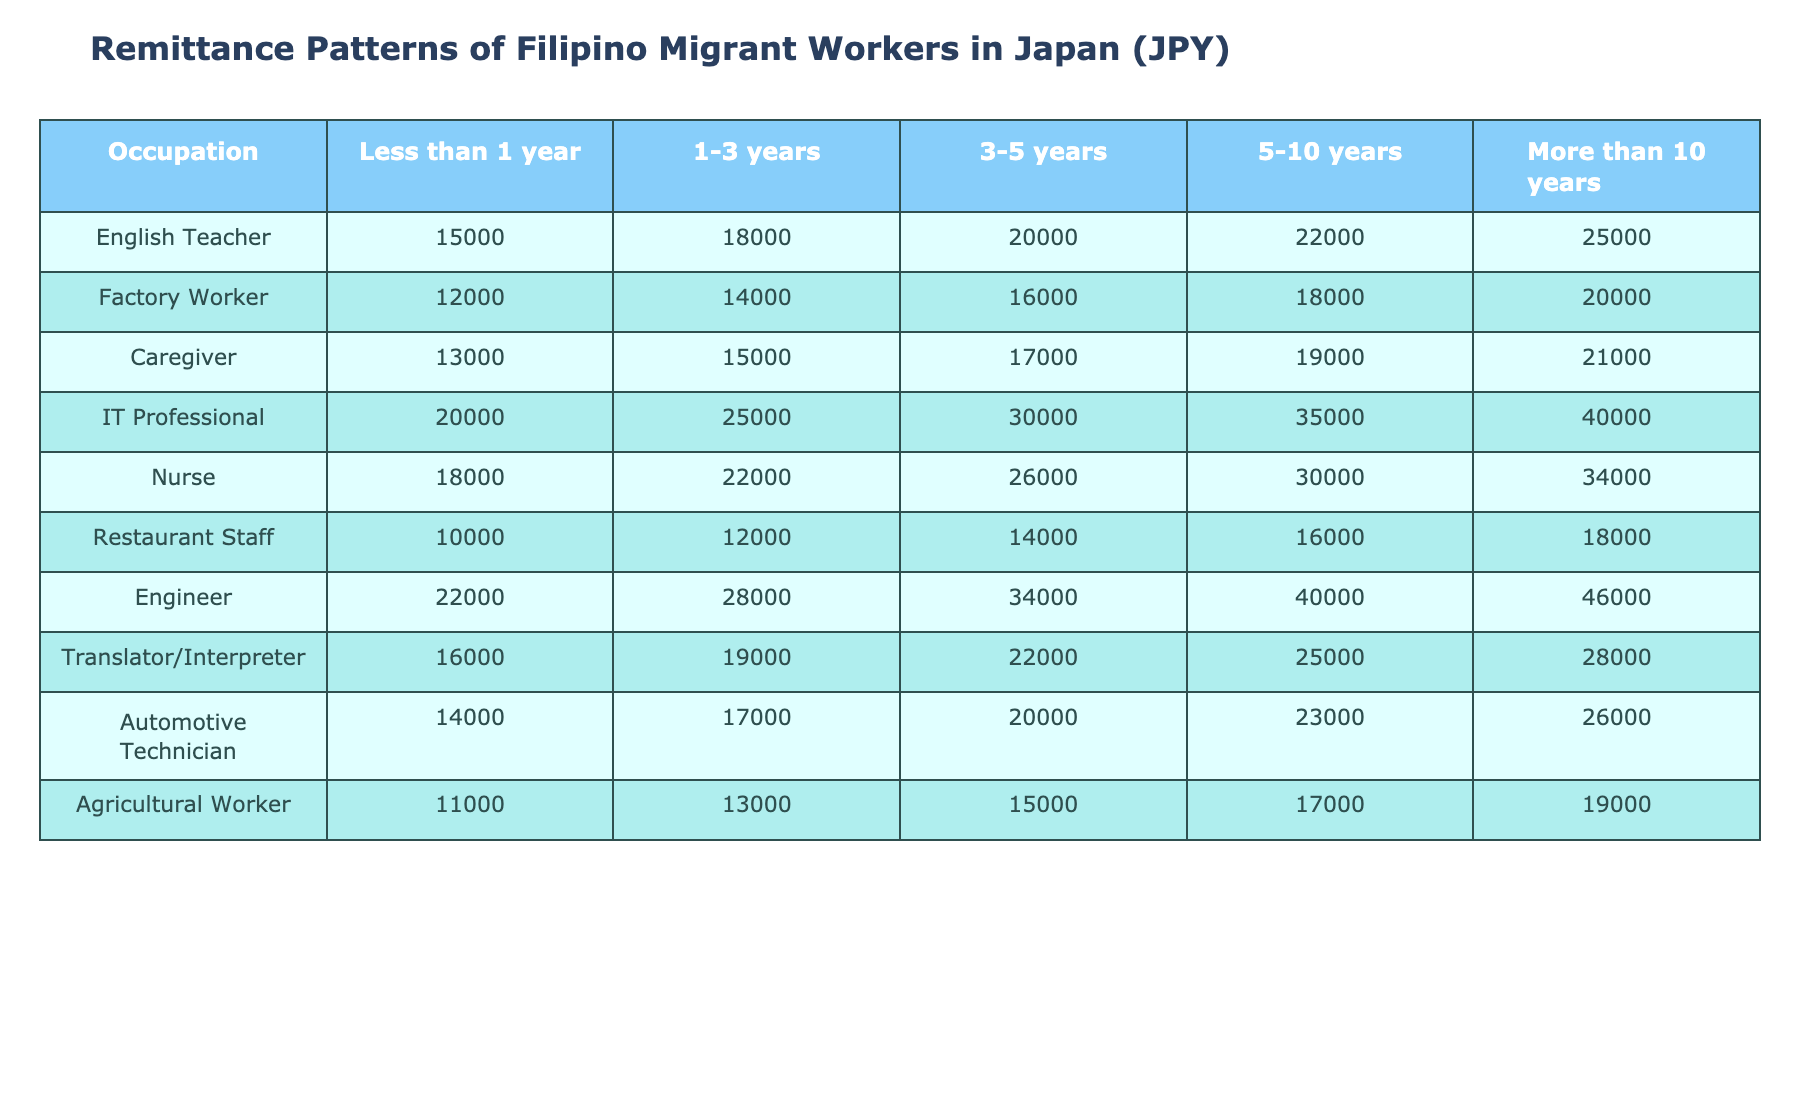What is the highest remittance amount for an English Teacher with over 10 years of stay? According to the table, the remittance amount for an English Teacher who has stayed more than 10 years is 25,000 JPY.
Answer: 25,000 JPY What is the average remittance of Factory Workers across all lengths of stay? To find the average, add up all the remittance amounts for Factory Workers: (12,000 + 14,000 + 16,000 + 18,000 + 20,000) = 80,000 JPY. There are 5 data points, so the average is 80,000/5 = 16,000 JPY.
Answer: 16,000 JPY Is the remittance amount for Nurses who stay for 3-5 years greater than that of Caregivers in the same duration? The remittance amount for Nurses for 3-5 years is 26,000 JPY, while for Caregivers it is 17,000 JPY. Since 26,000 > 17,000, the statement is true.
Answer: Yes Which occupation has the highest remittance amount for workers with 5 to 10 years of stay, and what is that amount? The table shows that for the 5 to 10 years category, the remittance amounts are Engineer (40,000), Nurse (30,000), IT Professional (35,000), etc. The highest among these is 40,000 JPY for Engineers.
Answer: Engineer, 40,000 JPY What is the difference in remittance amount between the least and most remitting occupations for agricultural workers? The remittance for Agricultural Workers is 11,000 JPY (least) and for IT Professional it is 20,000 JPY (most). The difference is 20,000 - 11,000 = 9,000 JPY.
Answer: 9,000 JPY For which occupation is the increase in remittance from the 1-3 year group to the 5-10 year group the greatest? The remittance increases for each occupation must be calculated: IT Professional (100,000), Nurse (80,000), and others. IT Professional shows the biggest increase of 35,000 - 25,000 = 10,000 JPY.
Answer: IT Professional How do the remittances of Automotive Technicians compare to those of Caregivers with less than 1 year of stay? The remittance for Automotive Technicians with less than 1 year is 14,000 JPY and for Caregivers it is 13,000 JPY. So, Automotive Technicians have a higher remittance by 1,000 JPY.
Answer: Higher by 1,000 JPY What is the median remittance for Translator/Interpreter after 3-5 years of stay? The remittance for Translator/Interpreter in the 3-5 years category is 22,000 JPY. Since this is a single value, it is also the median.
Answer: 22,000 JPY Which occupation's remittance amount sees the smallest increase over the period of less than 1 year to more than 10 years? The difference in remittance must be reviewed for each occupation. The smallest increase is seen in Restaurant Staff (from 10,000 to 18,000), an increase of 8,000 JPY.
Answer: Restaurant Staff What percentage of remittance do Caregivers send after 1-3 years compared to the highest amount in that category? The remittance for Caregivers after 1-3 years is 15,000 JPY and the highest (IT Professional) is 25,000 JPY. The percentage is (15,000/25,000) * 100 = 60%.
Answer: 60% 